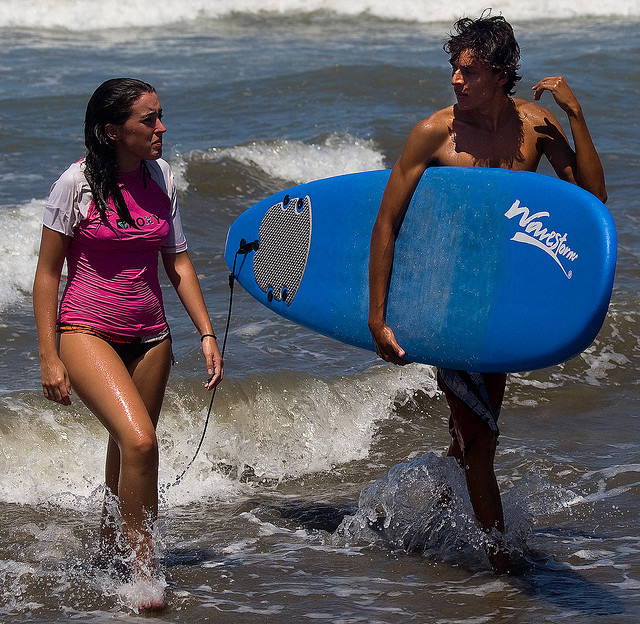Read and extract the text from this image. Wavestorms OXY 